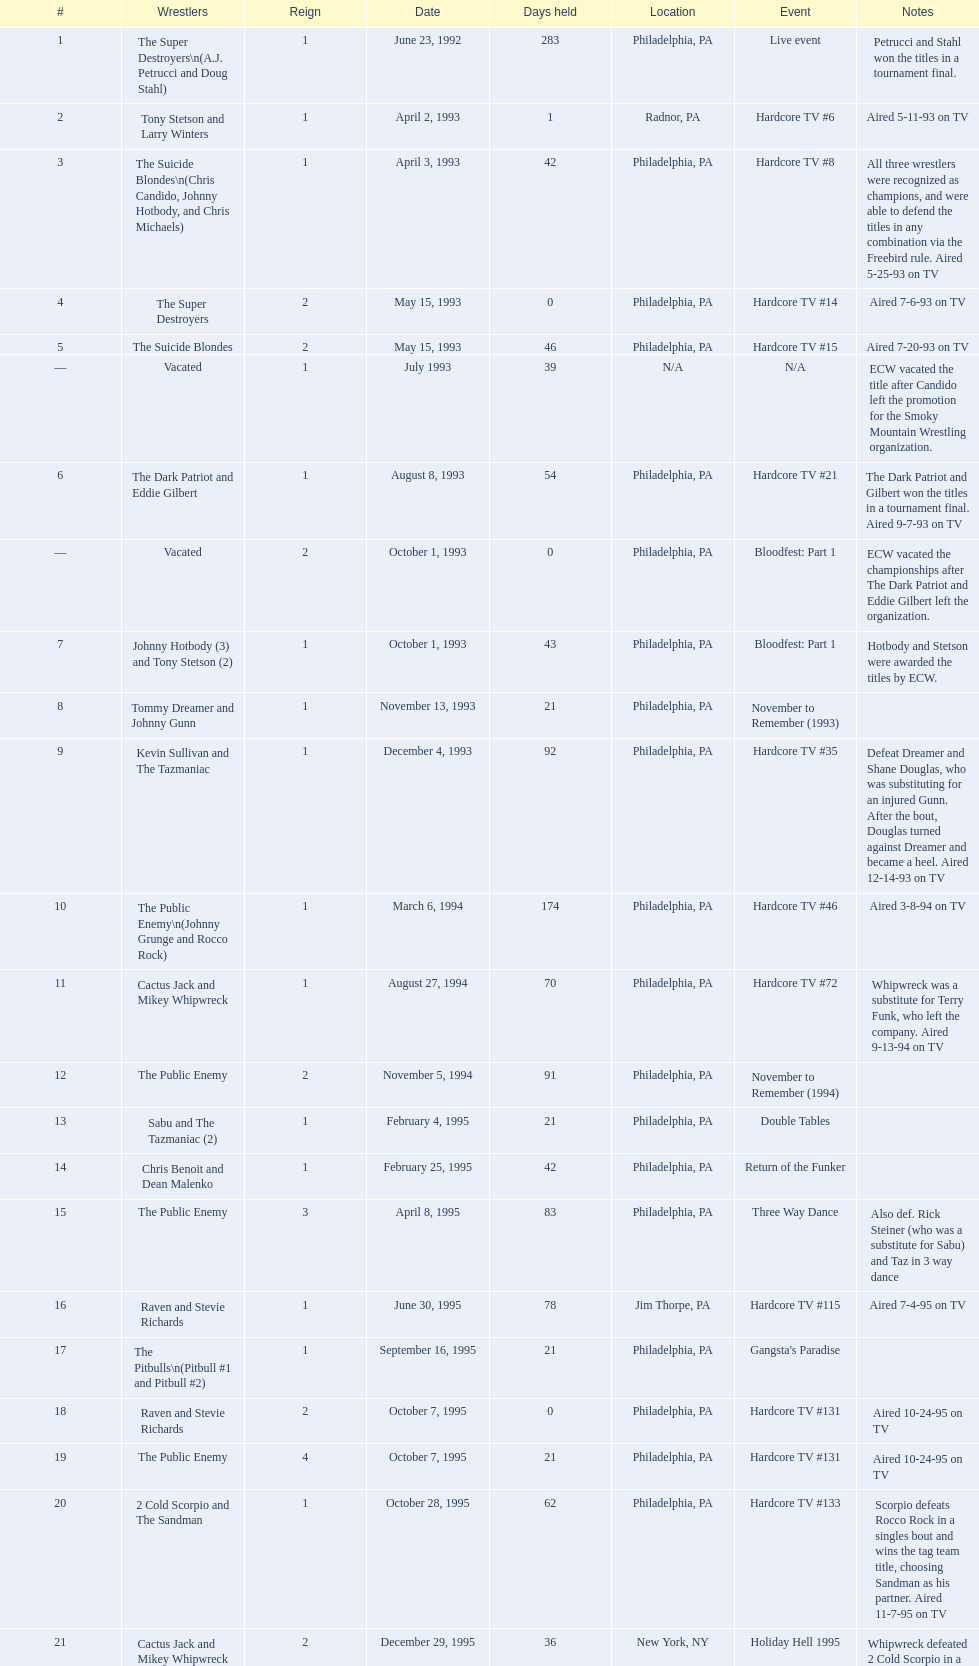How many days did hardcore tv #6 take? 1. 